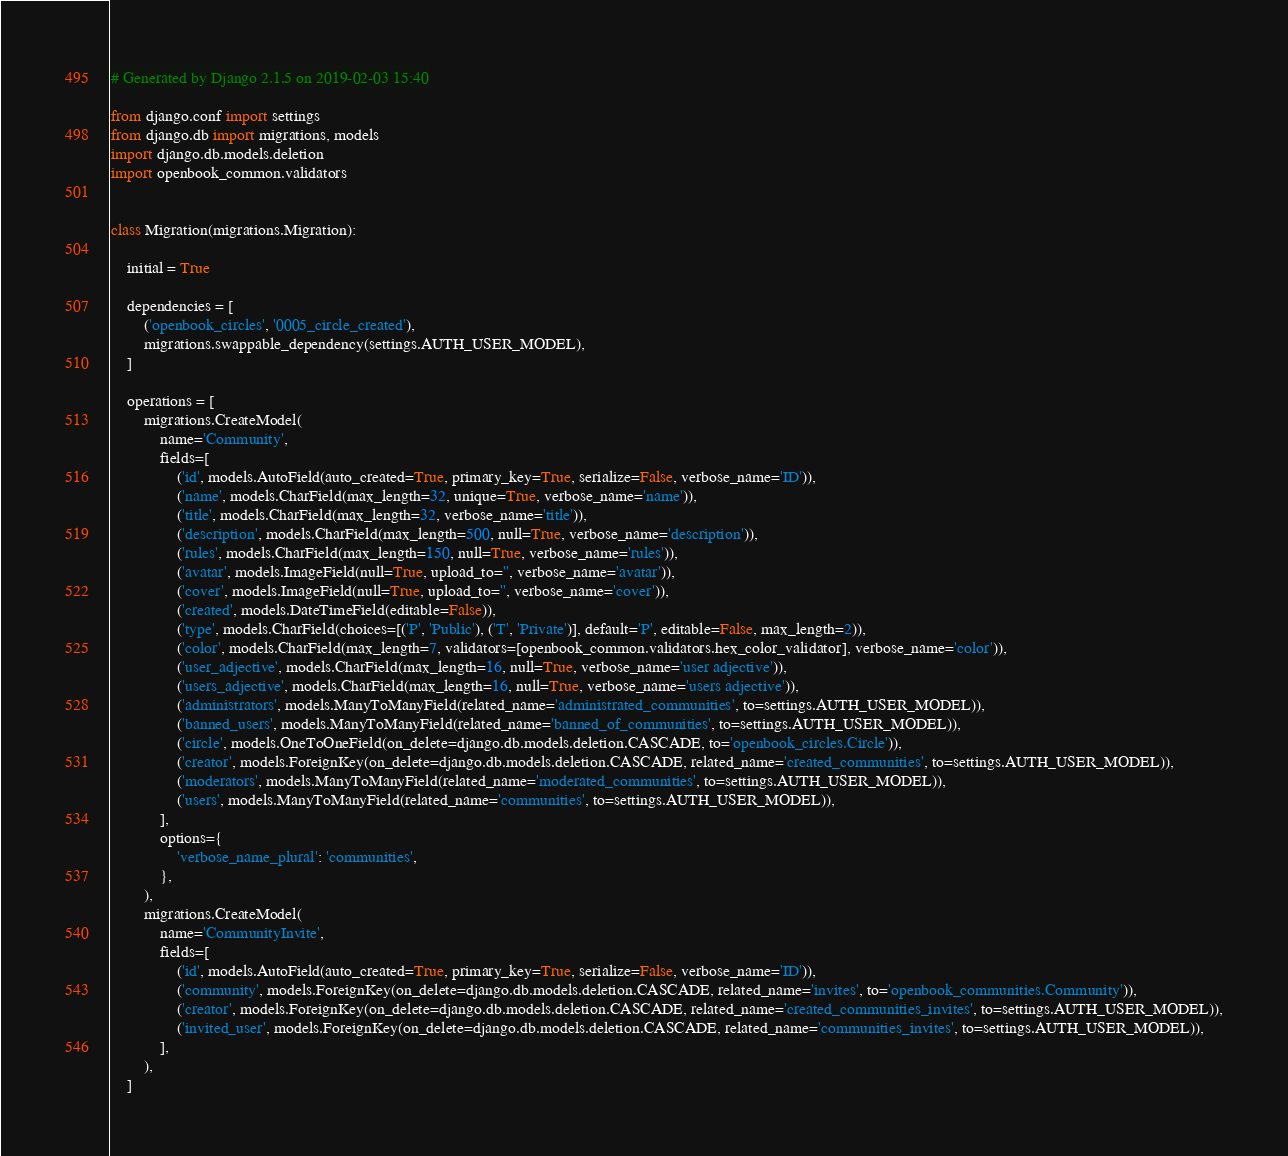<code> <loc_0><loc_0><loc_500><loc_500><_Python_># Generated by Django 2.1.5 on 2019-02-03 15:40

from django.conf import settings
from django.db import migrations, models
import django.db.models.deletion
import openbook_common.validators


class Migration(migrations.Migration):

    initial = True

    dependencies = [
        ('openbook_circles', '0005_circle_created'),
        migrations.swappable_dependency(settings.AUTH_USER_MODEL),
    ]

    operations = [
        migrations.CreateModel(
            name='Community',
            fields=[
                ('id', models.AutoField(auto_created=True, primary_key=True, serialize=False, verbose_name='ID')),
                ('name', models.CharField(max_length=32, unique=True, verbose_name='name')),
                ('title', models.CharField(max_length=32, verbose_name='title')),
                ('description', models.CharField(max_length=500, null=True, verbose_name='description')),
                ('rules', models.CharField(max_length=150, null=True, verbose_name='rules')),
                ('avatar', models.ImageField(null=True, upload_to='', verbose_name='avatar')),
                ('cover', models.ImageField(null=True, upload_to='', verbose_name='cover')),
                ('created', models.DateTimeField(editable=False)),
                ('type', models.CharField(choices=[('P', 'Public'), ('T', 'Private')], default='P', editable=False, max_length=2)),
                ('color', models.CharField(max_length=7, validators=[openbook_common.validators.hex_color_validator], verbose_name='color')),
                ('user_adjective', models.CharField(max_length=16, null=True, verbose_name='user adjective')),
                ('users_adjective', models.CharField(max_length=16, null=True, verbose_name='users adjective')),
                ('administrators', models.ManyToManyField(related_name='administrated_communities', to=settings.AUTH_USER_MODEL)),
                ('banned_users', models.ManyToManyField(related_name='banned_of_communities', to=settings.AUTH_USER_MODEL)),
                ('circle', models.OneToOneField(on_delete=django.db.models.deletion.CASCADE, to='openbook_circles.Circle')),
                ('creator', models.ForeignKey(on_delete=django.db.models.deletion.CASCADE, related_name='created_communities', to=settings.AUTH_USER_MODEL)),
                ('moderators', models.ManyToManyField(related_name='moderated_communities', to=settings.AUTH_USER_MODEL)),
                ('users', models.ManyToManyField(related_name='communities', to=settings.AUTH_USER_MODEL)),
            ],
            options={
                'verbose_name_plural': 'communities',
            },
        ),
        migrations.CreateModel(
            name='CommunityInvite',
            fields=[
                ('id', models.AutoField(auto_created=True, primary_key=True, serialize=False, verbose_name='ID')),
                ('community', models.ForeignKey(on_delete=django.db.models.deletion.CASCADE, related_name='invites', to='openbook_communities.Community')),
                ('creator', models.ForeignKey(on_delete=django.db.models.deletion.CASCADE, related_name='created_communities_invites', to=settings.AUTH_USER_MODEL)),
                ('invited_user', models.ForeignKey(on_delete=django.db.models.deletion.CASCADE, related_name='communities_invites', to=settings.AUTH_USER_MODEL)),
            ],
        ),
    ]
</code> 